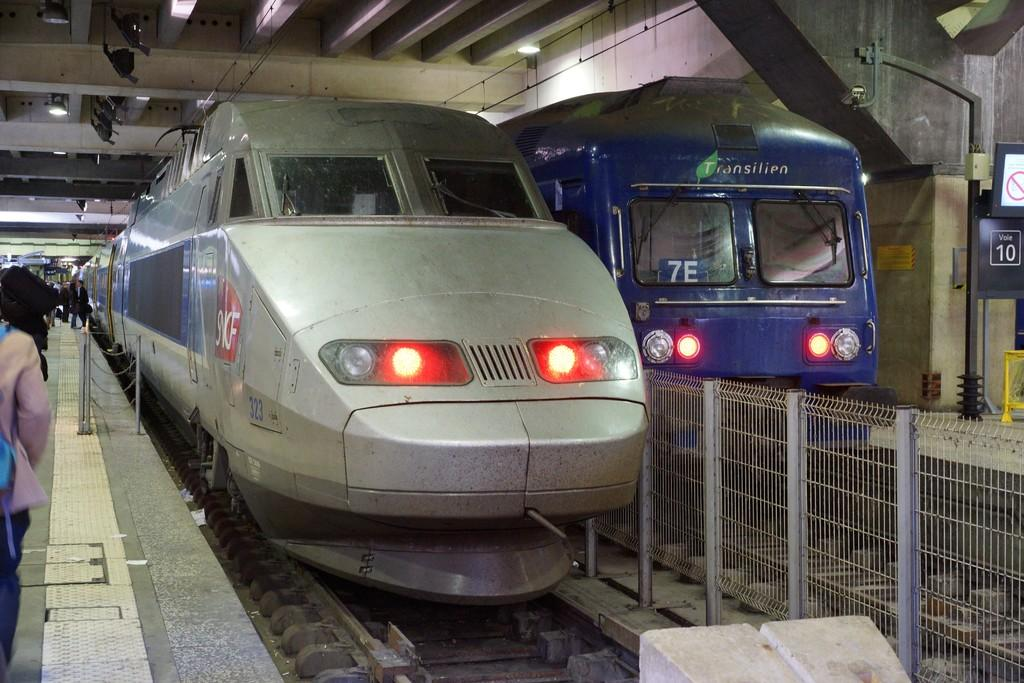<image>
Share a concise interpretation of the image provided. A gray bullet train is pulled up to a station with a blue one pulling up alongside it with the number 7E on its window. 